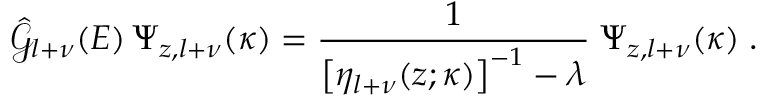<formula> <loc_0><loc_0><loc_500><loc_500>\hat { \mathcal { G } } _ { l + \nu } ( E ) \, \Psi _ { z , l + \nu } ( \kappa ) = \frac { 1 } { \left [ \eta _ { l + \nu } ( z ; \kappa ) \right ] ^ { - 1 } - \lambda } \, \Psi _ { z , l + \nu } ( \kappa ) \, .</formula> 